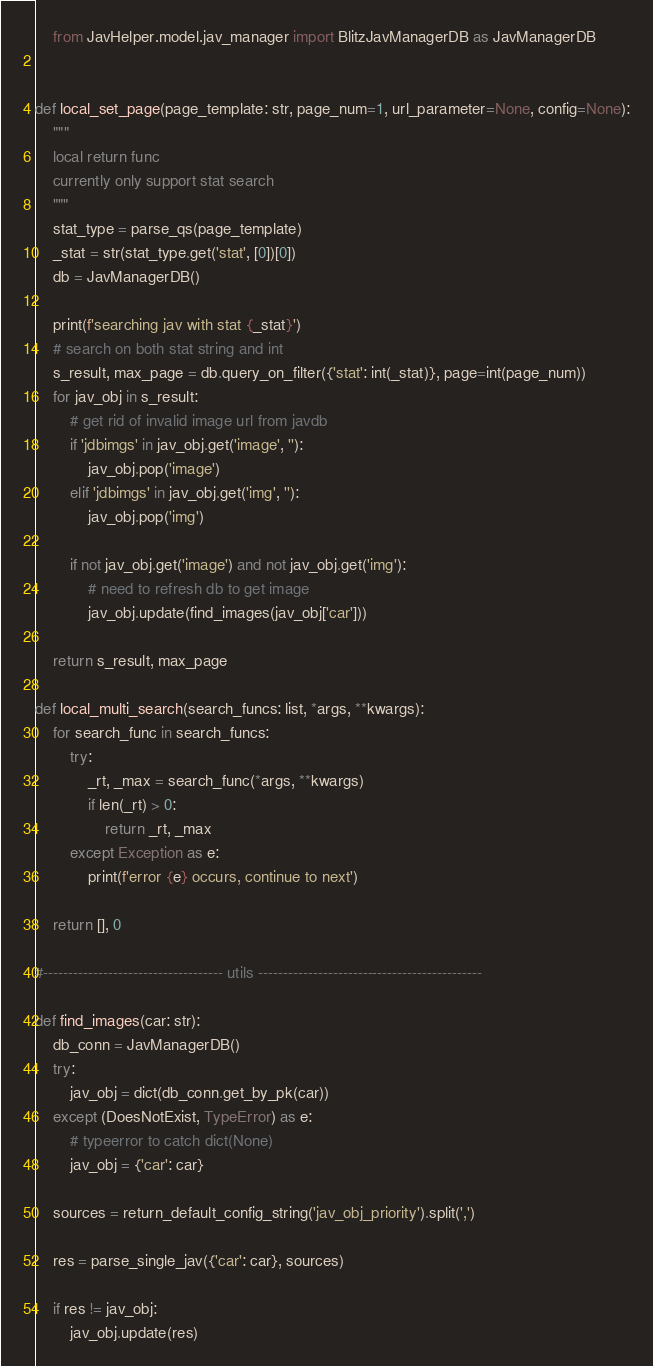Convert code to text. <code><loc_0><loc_0><loc_500><loc_500><_Python_>    from JavHelper.model.jav_manager import BlitzJavManagerDB as JavManagerDB


def local_set_page(page_template: str, page_num=1, url_parameter=None, config=None):
    """
    local return func
    currently only support stat search
    """
    stat_type = parse_qs(page_template)
    _stat = str(stat_type.get('stat', [0])[0])
    db = JavManagerDB()

    print(f'searching jav with stat {_stat}')
    # search on both stat string and int
    s_result, max_page = db.query_on_filter({'stat': int(_stat)}, page=int(page_num))
    for jav_obj in s_result:
        # get rid of invalid image url from javdb
        if 'jdbimgs' in jav_obj.get('image', ''):
            jav_obj.pop('image')
        elif 'jdbimgs' in jav_obj.get('img', ''):
            jav_obj.pop('img')

        if not jav_obj.get('image') and not jav_obj.get('img'):
            # need to refresh db to get image 
            jav_obj.update(find_images(jav_obj['car']))
    
    return s_result, max_page

def local_multi_search(search_funcs: list, *args, **kwargs):
    for search_func in search_funcs:
        try:
            _rt, _max = search_func(*args, **kwargs)
            if len(_rt) > 0:
                return _rt, _max
        except Exception as e:
            print(f'error {e} occurs, continue to next')
    
    return [], 0

#------------------------------------ utils ---------------------------------------------

def find_images(car: str):
    db_conn = JavManagerDB()
    try:
        jav_obj = dict(db_conn.get_by_pk(car))
    except (DoesNotExist, TypeError) as e:
        # typeerror to catch dict(None)
        jav_obj = {'car': car}

    sources = return_default_config_string('jav_obj_priority').split(',')

    res = parse_single_jav({'car': car}, sources)

    if res != jav_obj:
        jav_obj.update(res)</code> 